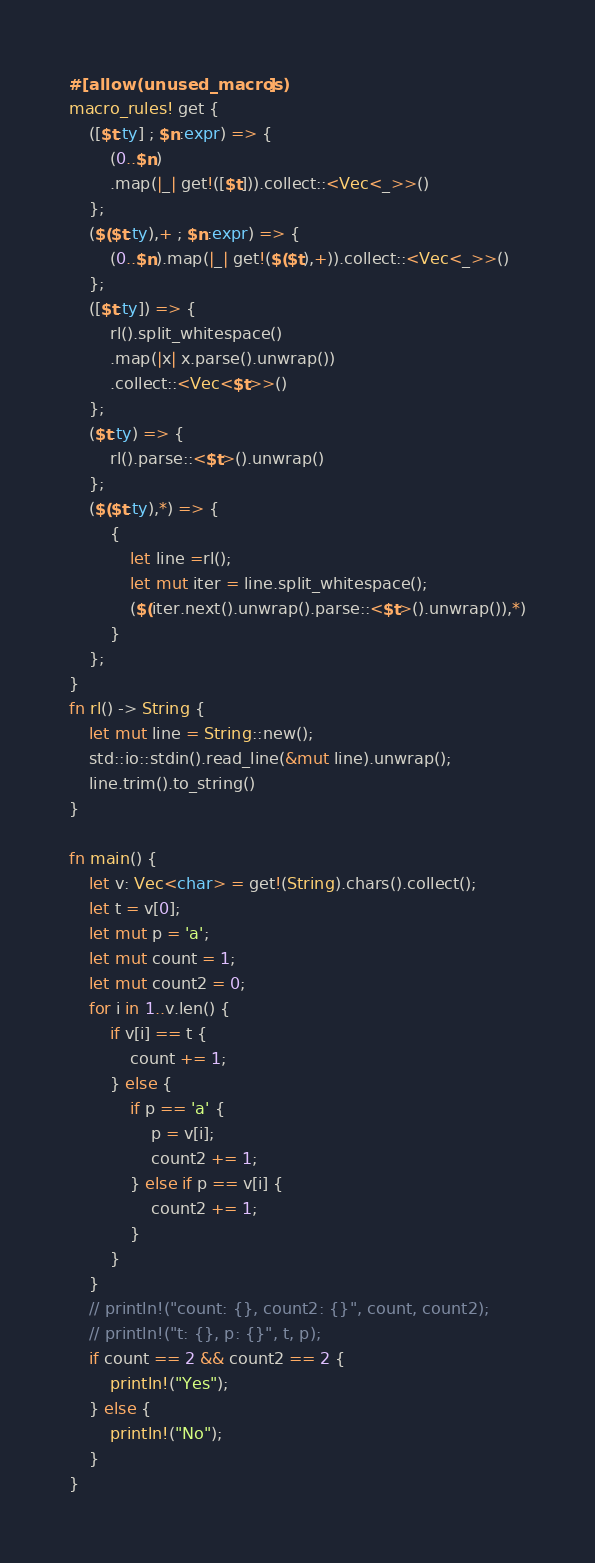Convert code to text. <code><loc_0><loc_0><loc_500><loc_500><_Rust_>#[allow(unused_macros)]
macro_rules! get {
    ([$t:ty] ; $n:expr) => {
        (0..$n)
        .map(|_| get!([$t])).collect::<Vec<_>>()
    };
    ($($t:ty),+ ; $n:expr) => {
        (0..$n).map(|_| get!($($t),+)).collect::<Vec<_>>()
    };
    ([$t:ty]) => {
        rl().split_whitespace()
        .map(|x| x.parse().unwrap())
        .collect::<Vec<$t>>()
    };
    ($t:ty) => {
        rl().parse::<$t>().unwrap()
    };
    ($($t:ty),*) => {
        {
            let line =rl();
            let mut iter = line.split_whitespace();
            ($(iter.next().unwrap().parse::<$t>().unwrap()),*)
        }
    };
}
fn rl() -> String {
    let mut line = String::new();
    std::io::stdin().read_line(&mut line).unwrap();
    line.trim().to_string()
}

fn main() {
    let v: Vec<char> = get!(String).chars().collect();
    let t = v[0];
    let mut p = 'a';
    let mut count = 1;
    let mut count2 = 0;
    for i in 1..v.len() {
        if v[i] == t {
            count += 1;
        } else {
            if p == 'a' {
                p = v[i];
                count2 += 1;
            } else if p == v[i] {
                count2 += 1;
            }
        }
    }
    // println!("count: {}, count2: {}", count, count2);
    // println!("t: {}, p: {}", t, p);
    if count == 2 && count2 == 2 {
        println!("Yes");
    } else {
        println!("No");
    }
}
</code> 